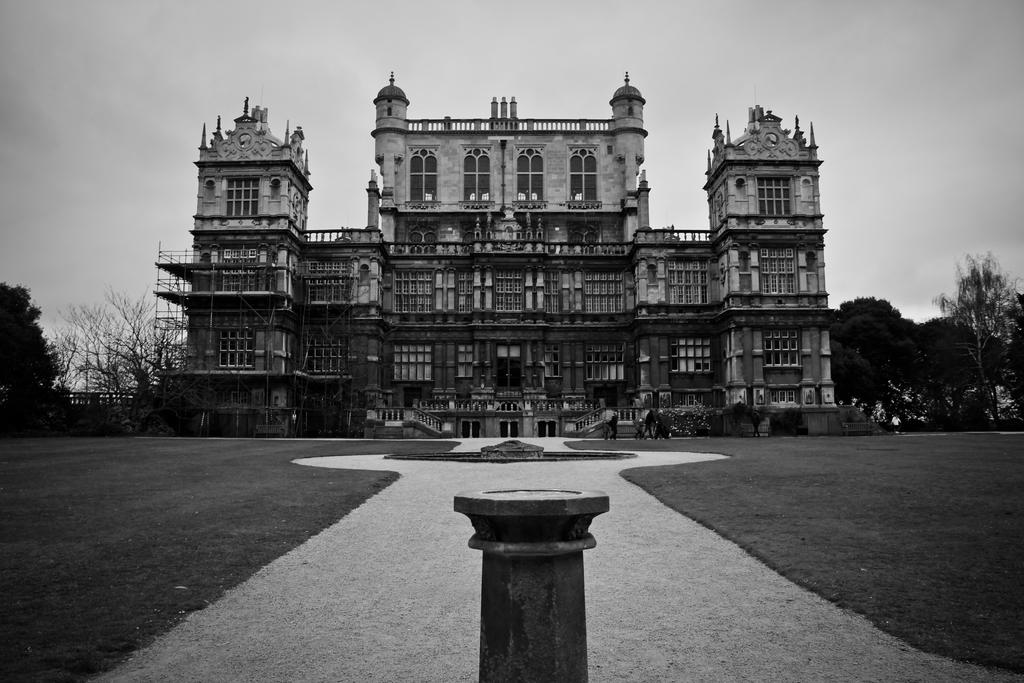What is the main structure in the image? There is a building in the center of the image. What is located at the bottom of the image? There is a road at the bottom of the image. What can be seen in the background of the image? There are trees and the sky visible in the background of the image. What type of pipe is visible in the image? There is no pipe present in the image. How many flags can be seen in the image? There are no flags visible in the image. 